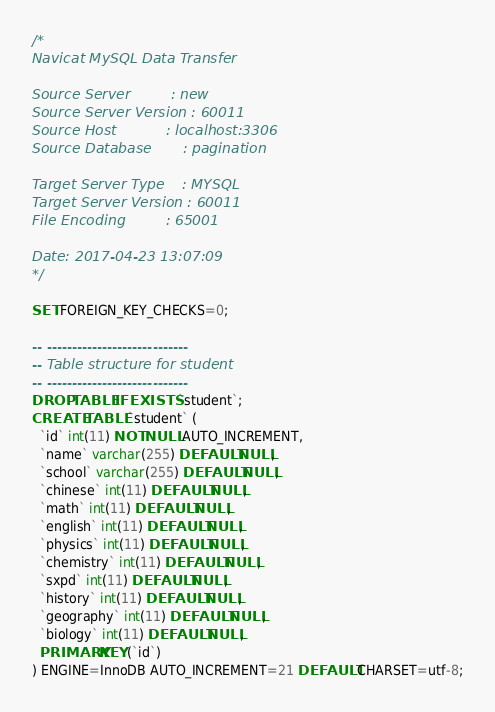Convert code to text. <code><loc_0><loc_0><loc_500><loc_500><_SQL_>/*
Navicat MySQL Data Transfer

Source Server         : new
Source Server Version : 60011
Source Host           : localhost:3306
Source Database       : pagination

Target Server Type    : MYSQL
Target Server Version : 60011
File Encoding         : 65001

Date: 2017-04-23 13:07:09
*/

SET FOREIGN_KEY_CHECKS=0;

-- ----------------------------
-- Table structure for student
-- ----------------------------
DROP TABLE IF EXISTS `student`;
CREATE TABLE `student` (
  `id` int(11) NOT NULL AUTO_INCREMENT,
  `name` varchar(255) DEFAULT NULL,
  `school` varchar(255) DEFAULT NULL,
  `chinese` int(11) DEFAULT NULL,
  `math` int(11) DEFAULT NULL,
  `english` int(11) DEFAULT NULL,
  `physics` int(11) DEFAULT NULL,
  `chemistry` int(11) DEFAULT NULL,
  `sxpd` int(11) DEFAULT NULL,
  `history` int(11) DEFAULT NULL,
  `geography` int(11) DEFAULT NULL,
  `biology` int(11) DEFAULT NULL,
  PRIMARY KEY (`id`)
) ENGINE=InnoDB AUTO_INCREMENT=21 DEFAULT CHARSET=utf-8;
</code> 